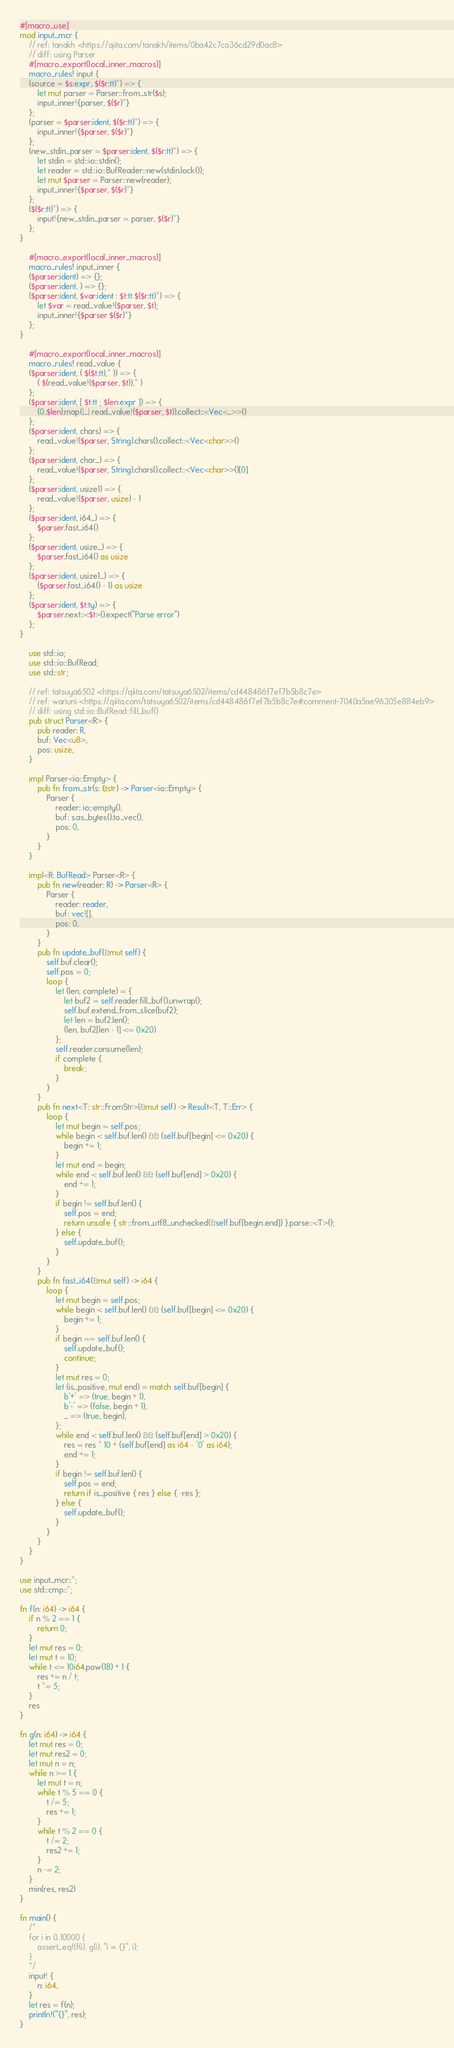<code> <loc_0><loc_0><loc_500><loc_500><_Rust_>#[macro_use]
mod input_mcr {
    // ref: tanakh <https://qiita.com/tanakh/items/0ba42c7ca36cd29d0ac8>
    // diff: using Parser
    #[macro_export(local_inner_macros)]
    macro_rules! input {
    (source = $s:expr, $($r:tt)*) => {
        let mut parser = Parser::from_str($s);
        input_inner!{parser, $($r)*}
    };
    (parser = $parser:ident, $($r:tt)*) => {
        input_inner!{$parser, $($r)*}
    };
    (new_stdin_parser = $parser:ident, $($r:tt)*) => {
        let stdin = std::io::stdin();
        let reader = std::io::BufReader::new(stdin.lock());
        let mut $parser = Parser::new(reader);
        input_inner!{$parser, $($r)*}
    };
    ($($r:tt)*) => {
        input!{new_stdin_parser = parser, $($r)*}
    };
}

    #[macro_export(local_inner_macros)]
    macro_rules! input_inner {
    ($parser:ident) => {};
    ($parser:ident, ) => {};
    ($parser:ident, $var:ident : $t:tt $($r:tt)*) => {
        let $var = read_value!($parser, $t);
        input_inner!{$parser $($r)*}
    };
}

    #[macro_export(local_inner_macros)]
    macro_rules! read_value {
    ($parser:ident, ( $($t:tt),* )) => {
        ( $(read_value!($parser, $t)),* )
    };
    ($parser:ident, [ $t:tt ; $len:expr ]) => {
        (0..$len).map(|_| read_value!($parser, $t)).collect::<Vec<_>>()
    };
    ($parser:ident, chars) => {
        read_value!($parser, String).chars().collect::<Vec<char>>()
    };
    ($parser:ident, char_) => {
        read_value!($parser, String).chars().collect::<Vec<char>>()[0]
    };
    ($parser:ident, usize1) => {
        read_value!($parser, usize) - 1
    };
    ($parser:ident, i64_) => {
        $parser.fast_i64()
    };
    ($parser:ident, usize_) => {
        $parser.fast_i64() as usize
    };
    ($parser:ident, usize1_) => {
        ($parser.fast_i64() - 1) as usize
    };
    ($parser:ident, $t:ty) => {
        $parser.next::<$t>().expect("Parse error")
    };
}

    use std::io;
    use std::io::BufRead;
    use std::str;

    // ref: tatsuya6502 <https://qiita.com/tatsuya6502/items/cd448486f7ef7b5b8c7e>
    // ref: wariuni <https://qiita.com/tatsuya6502/items/cd448486f7ef7b5b8c7e#comment-7040a5ae96305e884eb9>
    // diff: using std::io::BufRead::fill_buf()
    pub struct Parser<R> {
        pub reader: R,
        buf: Vec<u8>,
        pos: usize,
    }

    impl Parser<io::Empty> {
        pub fn from_str(s: &str) -> Parser<io::Empty> {
            Parser {
                reader: io::empty(),
                buf: s.as_bytes().to_vec(),
                pos: 0,
            }
        }
    }

    impl<R: BufRead> Parser<R> {
        pub fn new(reader: R) -> Parser<R> {
            Parser {
                reader: reader,
                buf: vec![],
                pos: 0,
            }
        }
        pub fn update_buf(&mut self) {
            self.buf.clear();
            self.pos = 0;
            loop {
                let (len, complete) = {
                    let buf2 = self.reader.fill_buf().unwrap();
                    self.buf.extend_from_slice(buf2);
                    let len = buf2.len();
                    (len, buf2[len - 1] <= 0x20)
                };
                self.reader.consume(len);
                if complete {
                    break;
                }
            }
        }
        pub fn next<T: str::FromStr>(&mut self) -> Result<T, T::Err> {
            loop {
                let mut begin = self.pos;
                while begin < self.buf.len() && (self.buf[begin] <= 0x20) {
                    begin += 1;
                }
                let mut end = begin;
                while end < self.buf.len() && (self.buf[end] > 0x20) {
                    end += 1;
                }
                if begin != self.buf.len() {
                    self.pos = end;
                    return unsafe { str::from_utf8_unchecked(&self.buf[begin..end]) }.parse::<T>();
                } else {
                    self.update_buf();
                }
            }
        }
        pub fn fast_i64(&mut self) -> i64 {
            loop {
                let mut begin = self.pos;
                while begin < self.buf.len() && (self.buf[begin] <= 0x20) {
                    begin += 1;
                }
                if begin == self.buf.len() {
                    self.update_buf();
                    continue;
                }
                let mut res = 0;
                let (is_positive, mut end) = match self.buf[begin] {
                    b'+' => (true, begin + 1),
                    b'-' => (false, begin + 1),
                    _ => (true, begin),
                };
                while end < self.buf.len() && (self.buf[end] > 0x20) {
                    res = res * 10 + (self.buf[end] as i64 - '0' as i64);
                    end += 1;
                }
                if begin != self.buf.len() {
                    self.pos = end;
                    return if is_positive { res } else { -res };
                } else {
                    self.update_buf();
                }
            }
        }
    }
}

use input_mcr::*;
use std::cmp::*;

fn f(n: i64) -> i64 {
    if n % 2 == 1 {
        return 0;
    }
    let mut res = 0;
    let mut t = 10;
    while t <= 10i64.pow(18) + 1 {
        res += n / t;
        t *= 5;
    }
    res
}

fn g(n: i64) -> i64 {
    let mut res = 0;
    let mut res2 = 0;
    let mut n = n;
    while n >= 1 {
        let mut t = n;
        while t % 5 == 0 {
            t /= 5;
            res += 1;
        }
        while t % 2 == 0 {
            t /= 2;
            res2 += 1;
        }
        n -= 2;
    }
    min(res, res2)
}

fn main() {
    /*
    for i in 0..10000 {
        assert_eq!(f(i), g(i), "i = {}", i);
    }
    */
    input! {
        n: i64,
    }
    let res = f(n);
    println!("{}", res);
}

</code> 